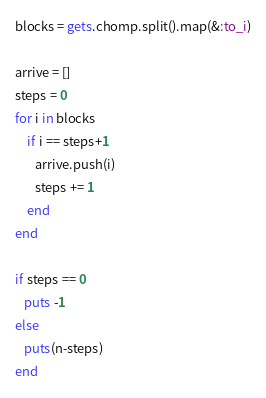Convert code to text. <code><loc_0><loc_0><loc_500><loc_500><_Ruby_>blocks = gets.chomp.split().map(&:to_i)

arrive = []
steps = 0
for i in blocks
    if i == steps+1
       arrive.push(i)
       steps += 1
    end
end

if steps == 0
   puts -1
else
   puts(n-steps)
end</code> 